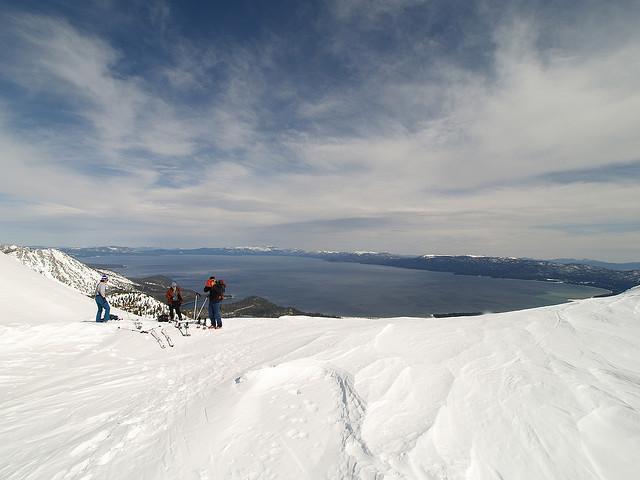How many cars can be seen?
Give a very brief answer. 0. 